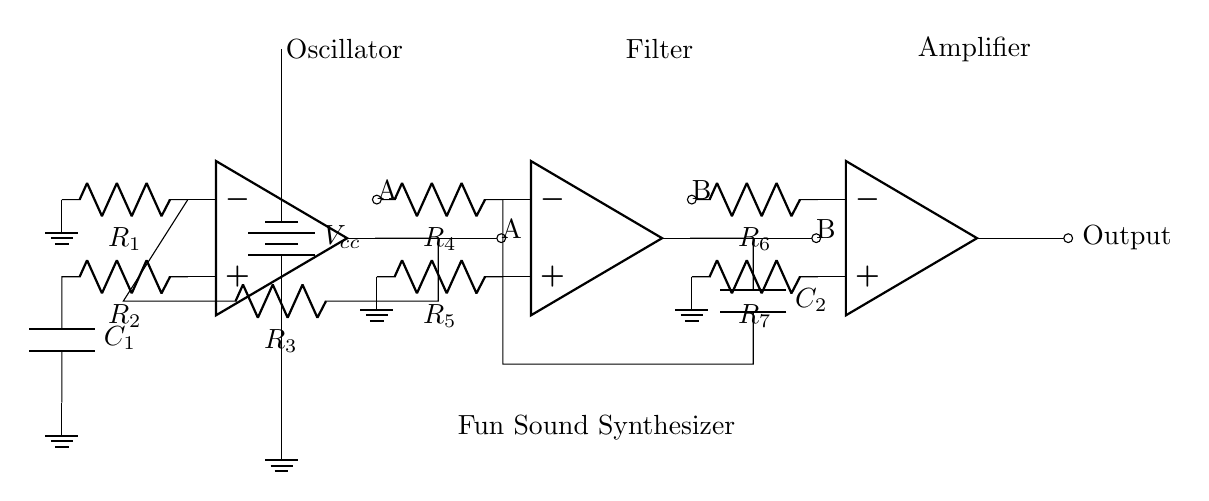What is the role of the first op-amp? The first op-amp acts as an oscillator, which generates a periodic waveform necessary for sound synthesis. This is indicated by the label "Oscillator" above the corresponding section and the connections to resistors and capacitor in its configuration.
Answer: Oscillator How many resistors are in the circuit? There are 6 resistors present in the circuit, labeled as R1 through R7. By counting each component in the schematic, one can verify this total.
Answer: 6 What component follows after the filter stage? The component that follows the filter stage is the amplifier, shown by the second op-amp in the diagram with the label "Amplifier." This can be seen by following the output of the filter to the input of the next op-amp.
Answer: Amplifier What is the function of capacitor C1? Capacitor C1 is used in the oscillator section to help establish the frequency of the generated waveform; it works in conjunction with the resistors to determine the timing characteristics of the oscillator. This understanding comes from the basic operation principles of RC circuits seen in the schematic.
Answer: Frequency control Which specific part of the circuit is responsible for producing the output sound? The output sound is produced by the final op-amp, labeled as "Output." This op-amp amplifies the signals that have passed through the previous stages, making the final sound audible. By tracing the path through the circuit, one can see the sound signal travels to this component last.
Answer: Output What kind of power source is indicated in this circuit? The circuit uses a battery as its power source, indicated by the label Vcc and the symbol for a battery in the schematic. This observation is made clear by the power connection leading from the battery to the other components.
Answer: Battery 